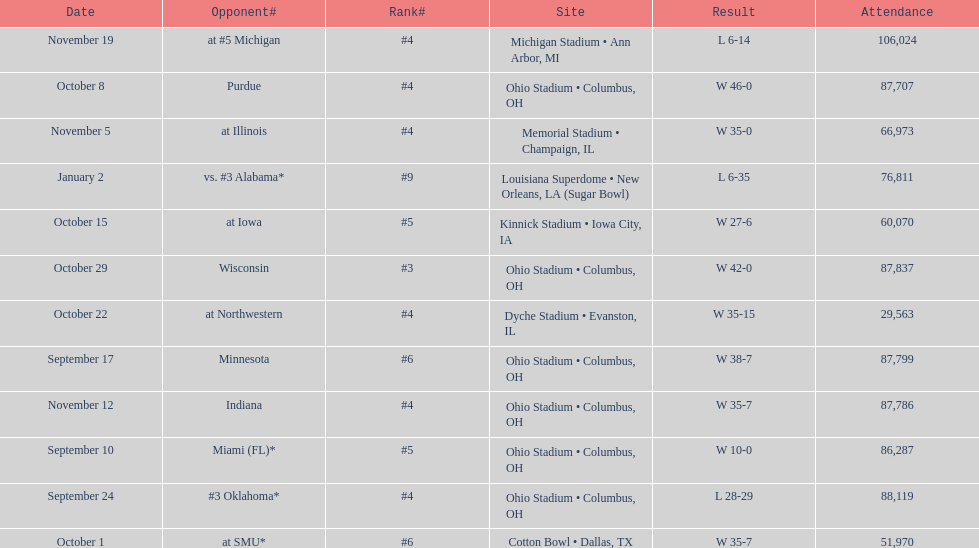What was the last game to be attended by fewer than 30,000 people? October 22. 